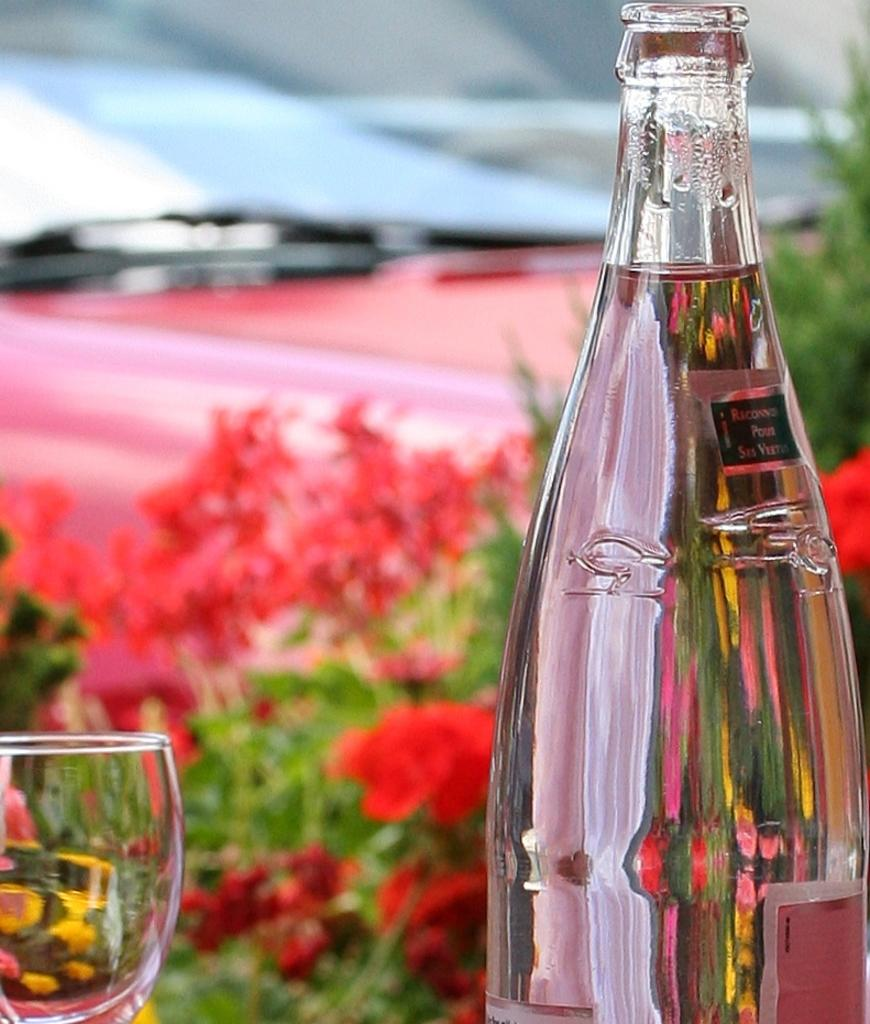What is contained in the bottle that is visible in the image? There is a bottle with a liquid in the image. What is another container that can be seen in the image? There is a drinking glass in the image. What type of plants are visible in the image? Flower plants are visible in the image. What type of credit card is being used to make a selection in the image? There is no credit card or selection process visible in the image. 